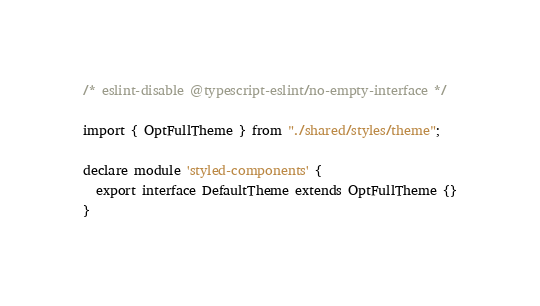Convert code to text. <code><loc_0><loc_0><loc_500><loc_500><_TypeScript_>/* eslint-disable @typescript-eslint/no-empty-interface */

import { OptFullTheme } from "./shared/styles/theme";

declare module 'styled-components' {
  export interface DefaultTheme extends OptFullTheme {}
}
</code> 